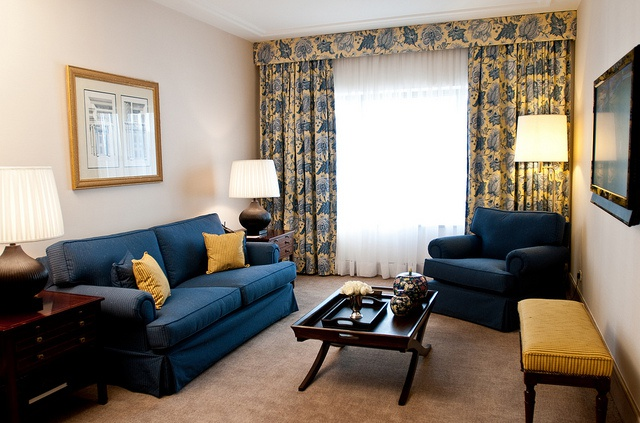Describe the objects in this image and their specific colors. I can see couch in ivory, black, blue, darkblue, and gray tones, chair in ivory, black, darkblue, blue, and gray tones, tv in ivory, black, gray, darkgray, and tan tones, dining table in ivory, black, lightblue, darkgray, and gray tones, and potted plant in ivory, black, tan, beige, and darkgray tones in this image. 